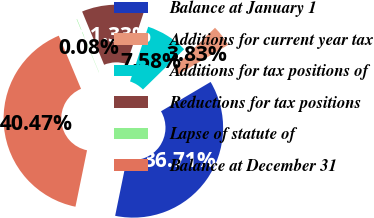<chart> <loc_0><loc_0><loc_500><loc_500><pie_chart><fcel>Balance at January 1<fcel>Additions for current year tax<fcel>Additions for tax positions of<fcel>Reductions for tax positions<fcel>Lapse of statute of<fcel>Balance at December 31<nl><fcel>36.71%<fcel>3.83%<fcel>7.58%<fcel>11.33%<fcel>0.08%<fcel>40.47%<nl></chart> 